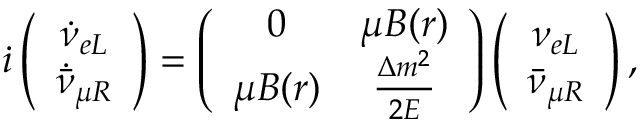Convert formula to latex. <formula><loc_0><loc_0><loc_500><loc_500>\dot { \imath } \left ( \begin{array} { c } { { \dot { \nu } _ { e L } } } \\ { { \dot { \bar { \nu } } _ { \mu R } } } \end{array} \right ) = \left ( \begin{array} { c c } { 0 } & { \mu B ( r ) } \\ { \mu B ( r ) } & { { \frac { \Delta m ^ { 2 } } { 2 E } } } \end{array} \right ) \left ( \begin{array} { c } { { \nu _ { e L } } } \\ { { \bar { \nu } _ { \mu R } } } \end{array} \right ) ,</formula> 